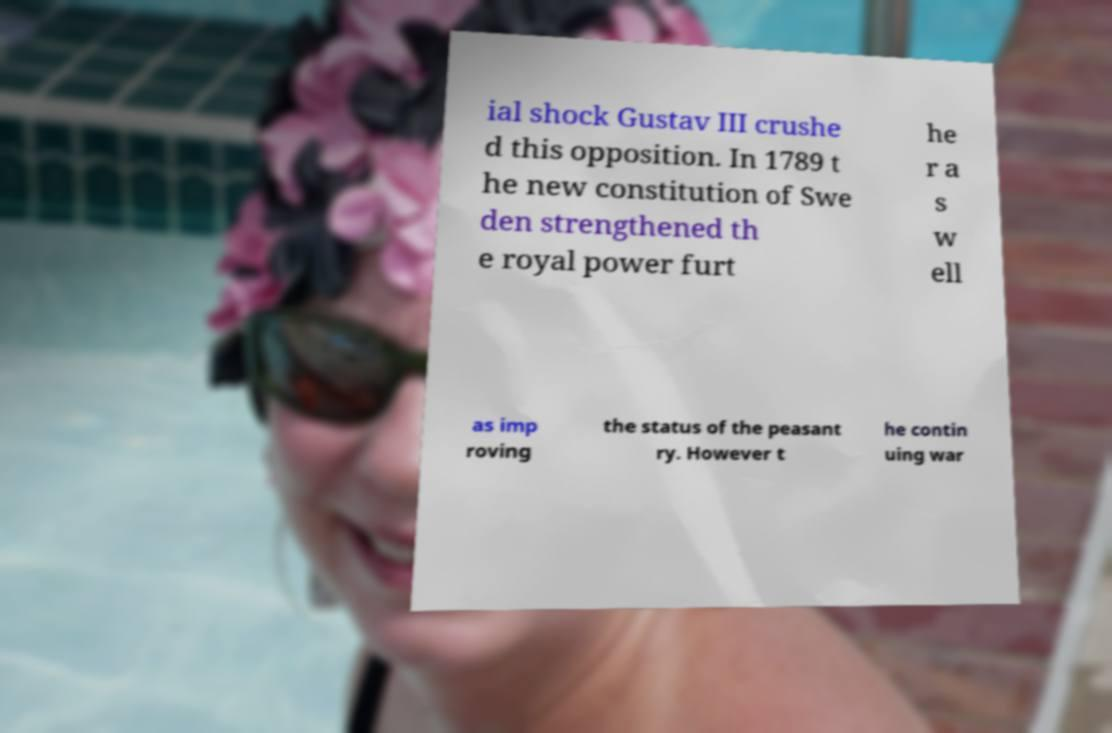There's text embedded in this image that I need extracted. Can you transcribe it verbatim? ial shock Gustav III crushe d this opposition. In 1789 t he new constitution of Swe den strengthened th e royal power furt he r a s w ell as imp roving the status of the peasant ry. However t he contin uing war 